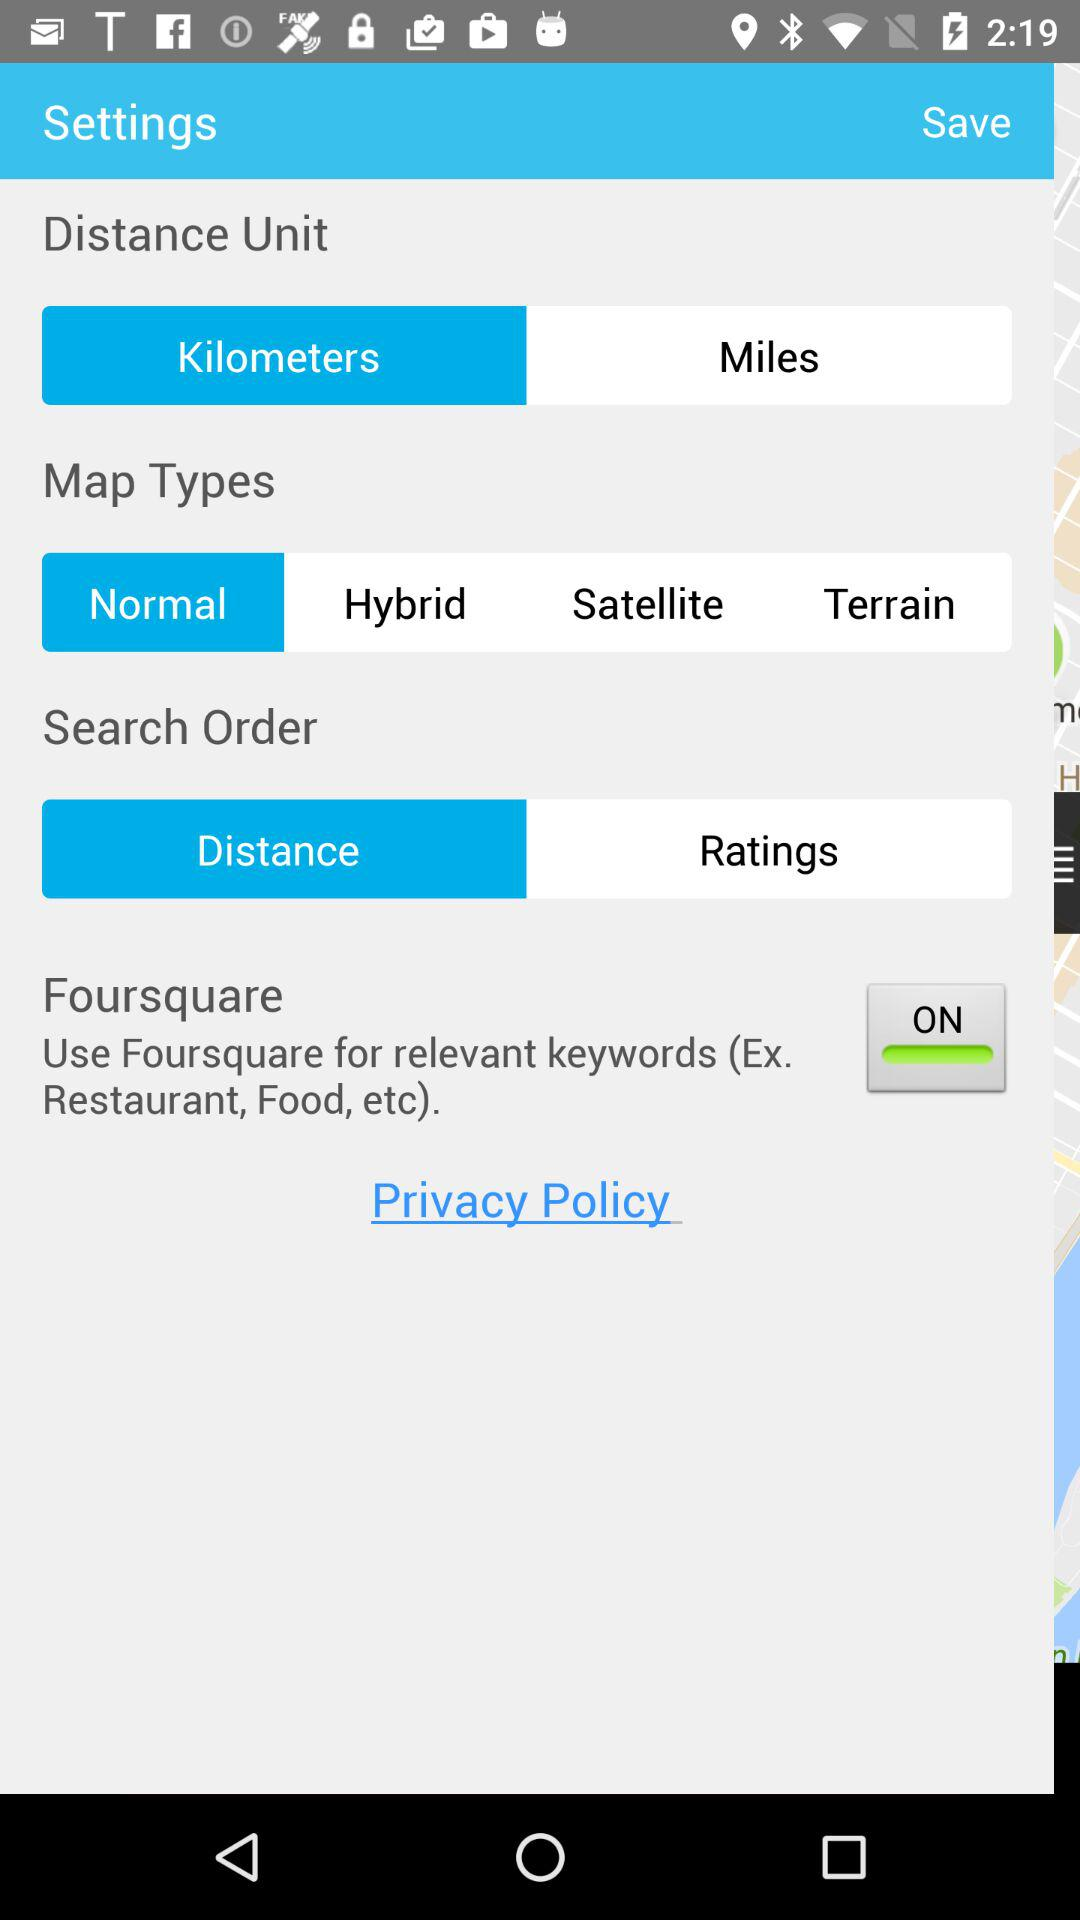For what setting is the "Kilometres" selected? The setting is "Distance Unit". 